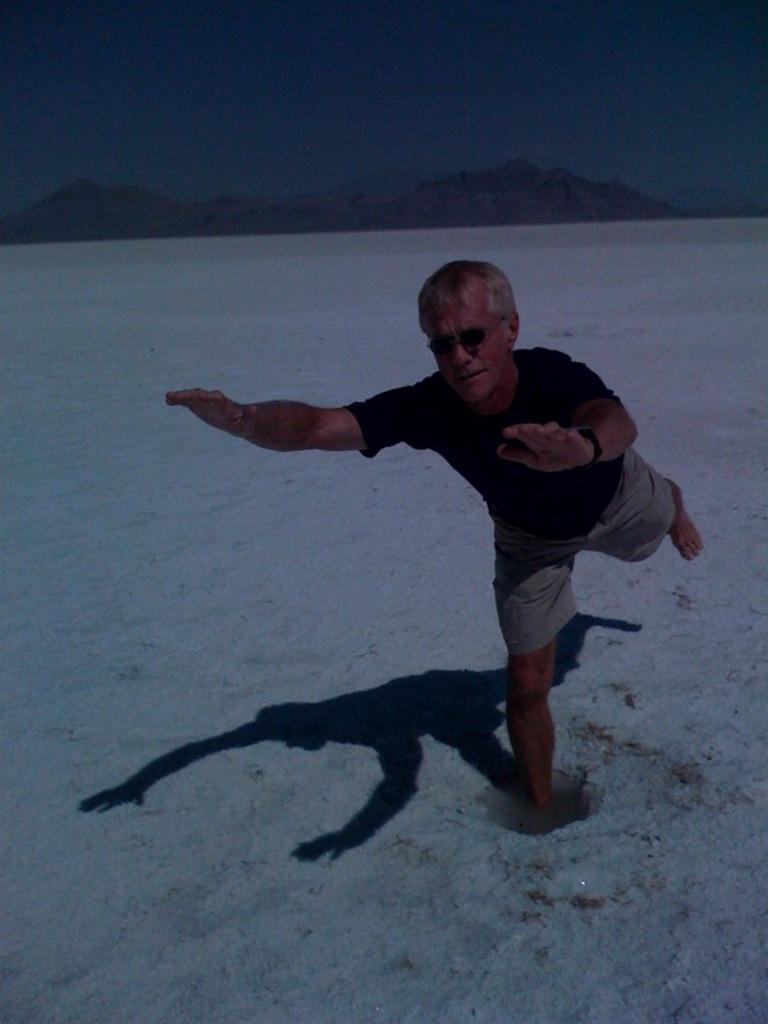What is the person in the image doing? The person is standing in the image, with one leg in the water. What is the water's location in relation to the person? The water is on the surface, and the person has one leg in it. What can be seen in the background of the image? There are mountains and the sky visible in the background of the image. How many eyes does the lead have in the image? There is no lead present in the image, and therefore no eyes can be attributed to it. 